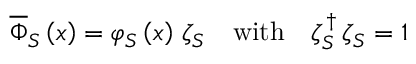<formula> <loc_0><loc_0><loc_500><loc_500>\begin{array} { r } { \overline { \Phi } _ { S } \left ( x \right ) = \varphi _ { S } \left ( x \right ) \, \zeta _ { S } \quad w i t h \quad \zeta _ { S } ^ { \, \dag } \, \zeta _ { S } = 1 } \end{array}</formula> 